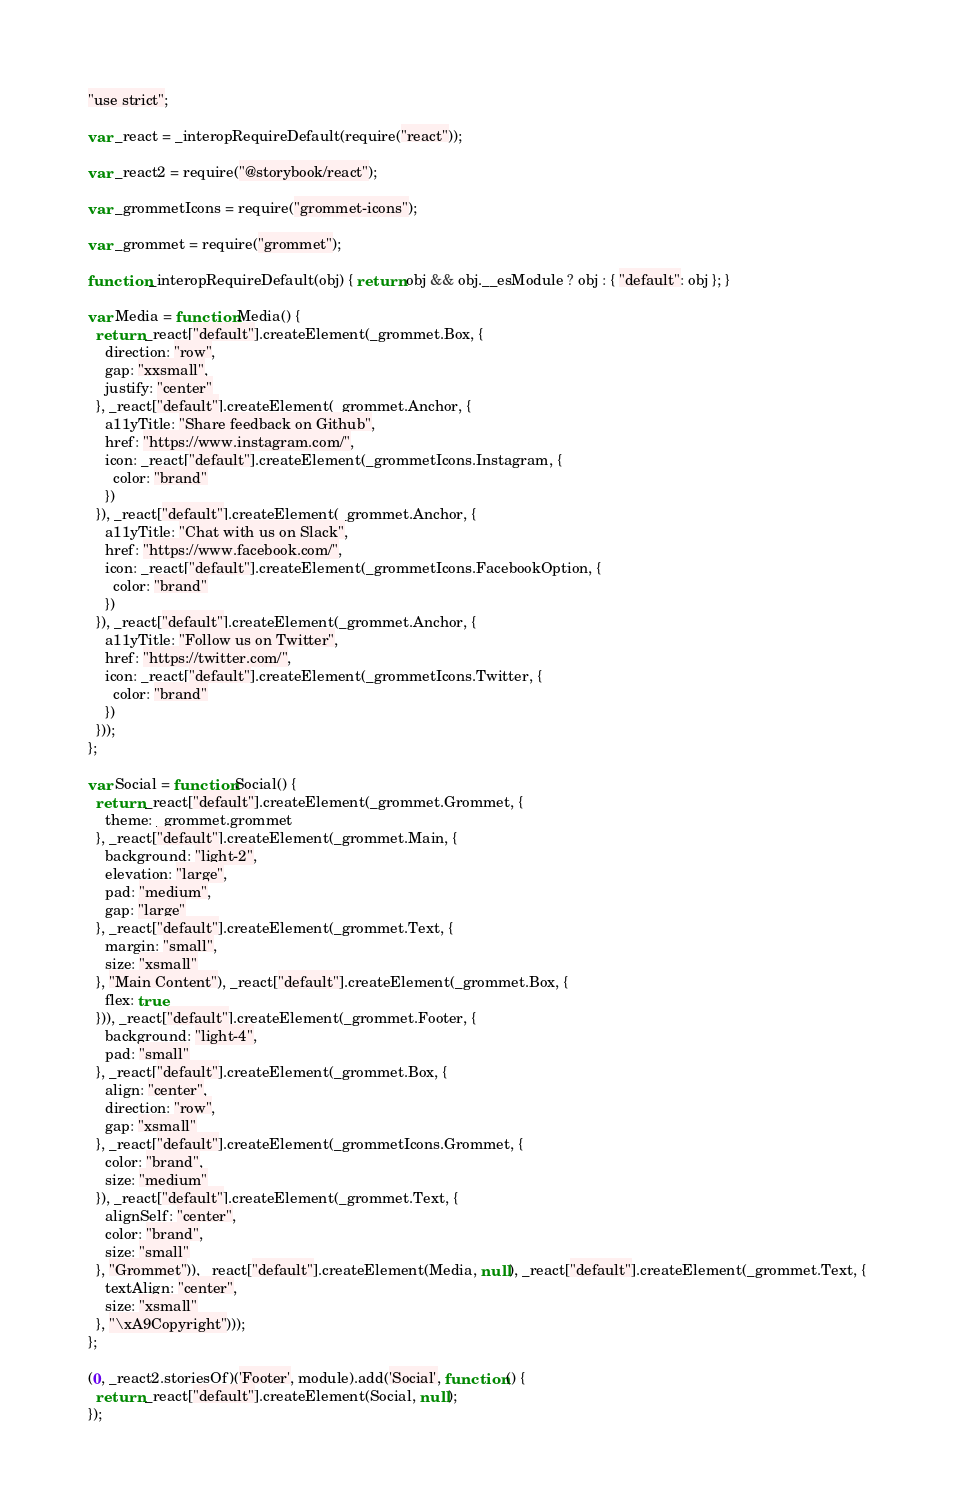<code> <loc_0><loc_0><loc_500><loc_500><_JavaScript_>"use strict";

var _react = _interopRequireDefault(require("react"));

var _react2 = require("@storybook/react");

var _grommetIcons = require("grommet-icons");

var _grommet = require("grommet");

function _interopRequireDefault(obj) { return obj && obj.__esModule ? obj : { "default": obj }; }

var Media = function Media() {
  return _react["default"].createElement(_grommet.Box, {
    direction: "row",
    gap: "xxsmall",
    justify: "center"
  }, _react["default"].createElement(_grommet.Anchor, {
    a11yTitle: "Share feedback on Github",
    href: "https://www.instagram.com/",
    icon: _react["default"].createElement(_grommetIcons.Instagram, {
      color: "brand"
    })
  }), _react["default"].createElement(_grommet.Anchor, {
    a11yTitle: "Chat with us on Slack",
    href: "https://www.facebook.com/",
    icon: _react["default"].createElement(_grommetIcons.FacebookOption, {
      color: "brand"
    })
  }), _react["default"].createElement(_grommet.Anchor, {
    a11yTitle: "Follow us on Twitter",
    href: "https://twitter.com/",
    icon: _react["default"].createElement(_grommetIcons.Twitter, {
      color: "brand"
    })
  }));
};

var Social = function Social() {
  return _react["default"].createElement(_grommet.Grommet, {
    theme: _grommet.grommet
  }, _react["default"].createElement(_grommet.Main, {
    background: "light-2",
    elevation: "large",
    pad: "medium",
    gap: "large"
  }, _react["default"].createElement(_grommet.Text, {
    margin: "small",
    size: "xsmall"
  }, "Main Content"), _react["default"].createElement(_grommet.Box, {
    flex: true
  })), _react["default"].createElement(_grommet.Footer, {
    background: "light-4",
    pad: "small"
  }, _react["default"].createElement(_grommet.Box, {
    align: "center",
    direction: "row",
    gap: "xsmall"
  }, _react["default"].createElement(_grommetIcons.Grommet, {
    color: "brand",
    size: "medium"
  }), _react["default"].createElement(_grommet.Text, {
    alignSelf: "center",
    color: "brand",
    size: "small"
  }, "Grommet")), _react["default"].createElement(Media, null), _react["default"].createElement(_grommet.Text, {
    textAlign: "center",
    size: "xsmall"
  }, "\xA9Copyright")));
};

(0, _react2.storiesOf)('Footer', module).add('Social', function () {
  return _react["default"].createElement(Social, null);
});</code> 